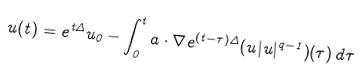<formula> <loc_0><loc_0><loc_500><loc_500>u ( t ) = e ^ { t \Delta } u _ { 0 } - \int _ { 0 } ^ { t } a \cdot \nabla e ^ { ( t - \tau ) \Delta } ( u | u | ^ { q - 1 } ) ( \tau ) \, d \tau</formula> 